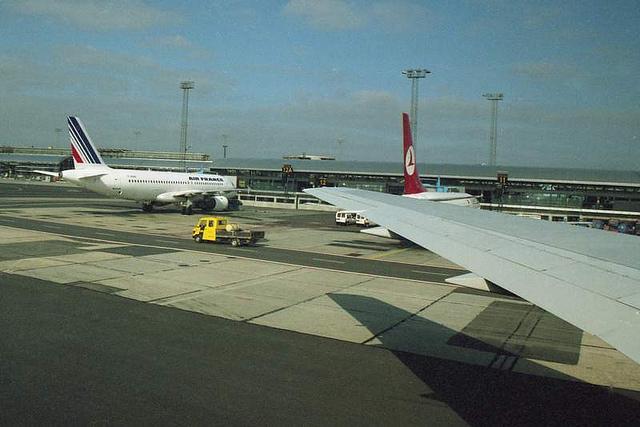What kind of aircrafts are these?
Concise answer only. Planes. What color is the truck?
Concise answer only. Yellow. Is it cloudy?
Give a very brief answer. Yes. 